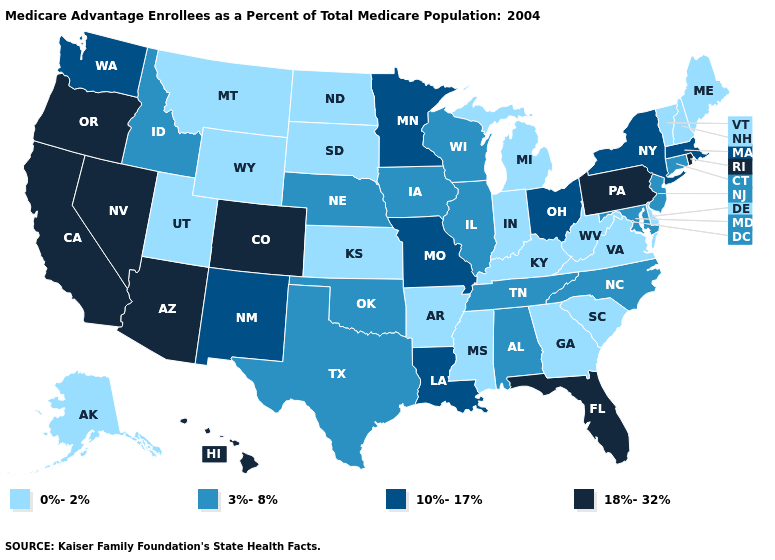What is the lowest value in the South?
Concise answer only. 0%-2%. Name the states that have a value in the range 3%-8%?
Concise answer only. Alabama, Connecticut, Iowa, Idaho, Illinois, Maryland, North Carolina, Nebraska, New Jersey, Oklahoma, Tennessee, Texas, Wisconsin. What is the lowest value in the Northeast?
Short answer required. 0%-2%. What is the lowest value in the USA?
Write a very short answer. 0%-2%. Among the states that border Wyoming , does Colorado have the highest value?
Short answer required. Yes. Which states have the highest value in the USA?
Write a very short answer. Arizona, California, Colorado, Florida, Hawaii, Nevada, Oregon, Pennsylvania, Rhode Island. What is the value of Wyoming?
Keep it brief. 0%-2%. What is the value of Missouri?
Give a very brief answer. 10%-17%. What is the value of Montana?
Keep it brief. 0%-2%. Name the states that have a value in the range 18%-32%?
Quick response, please. Arizona, California, Colorado, Florida, Hawaii, Nevada, Oregon, Pennsylvania, Rhode Island. Name the states that have a value in the range 10%-17%?
Quick response, please. Louisiana, Massachusetts, Minnesota, Missouri, New Mexico, New York, Ohio, Washington. Among the states that border New York , which have the lowest value?
Be succinct. Vermont. What is the highest value in the West ?
Short answer required. 18%-32%. Name the states that have a value in the range 0%-2%?
Be succinct. Alaska, Arkansas, Delaware, Georgia, Indiana, Kansas, Kentucky, Maine, Michigan, Mississippi, Montana, North Dakota, New Hampshire, South Carolina, South Dakota, Utah, Virginia, Vermont, West Virginia, Wyoming. What is the value of Hawaii?
Write a very short answer. 18%-32%. 